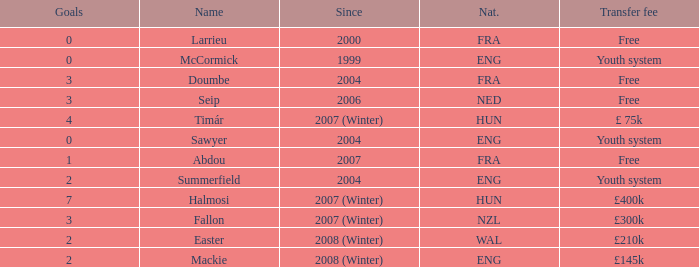What is the nationality of the player with a transfer fee of £400k? HUN. 